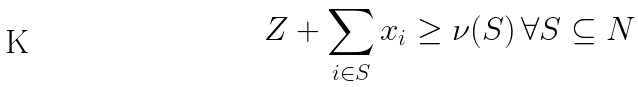Convert formula to latex. <formula><loc_0><loc_0><loc_500><loc_500>Z + \sum _ { i \in S } x _ { i } \geq \nu ( S ) \, \forall S \subseteq N</formula> 